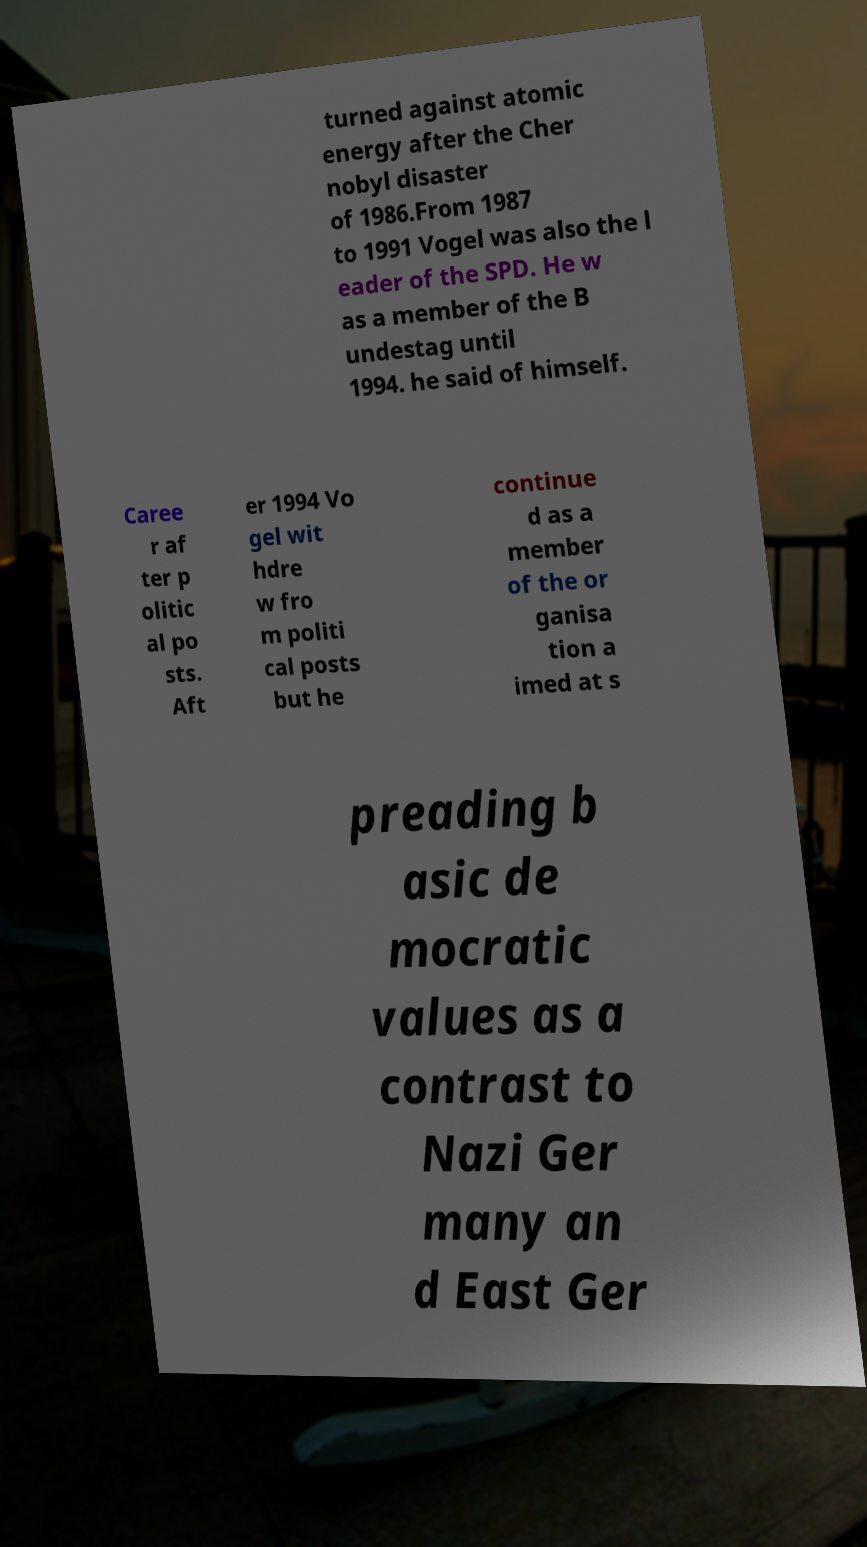Can you read and provide the text displayed in the image?This photo seems to have some interesting text. Can you extract and type it out for me? turned against atomic energy after the Cher nobyl disaster of 1986.From 1987 to 1991 Vogel was also the l eader of the SPD. He w as a member of the B undestag until 1994. he said of himself. Caree r af ter p olitic al po sts. Aft er 1994 Vo gel wit hdre w fro m politi cal posts but he continue d as a member of the or ganisa tion a imed at s preading b asic de mocratic values as a contrast to Nazi Ger many an d East Ger 